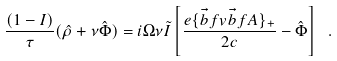Convert formula to latex. <formula><loc_0><loc_0><loc_500><loc_500>\frac { ( 1 - I ) } { \tau } ( \hat { \rho } + \nu \hat { \Phi } ) = i \Omega \nu \tilde { I } \left [ \frac { e \{ \vec { b } f v \vec { b } f A \} _ { + } } { 2 c } - \hat { \Phi } \right ] \ .</formula> 